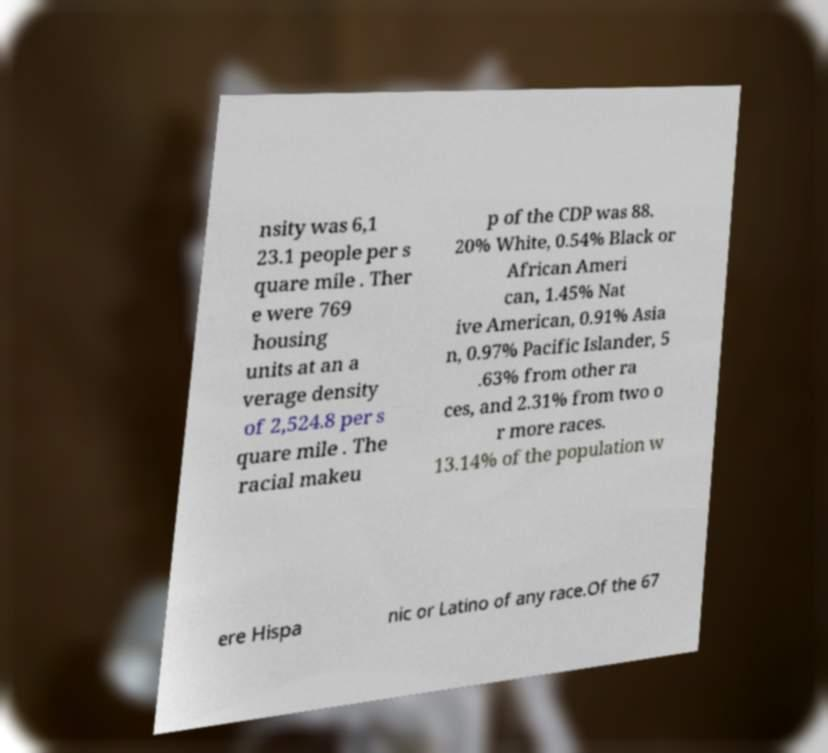Could you extract and type out the text from this image? nsity was 6,1 23.1 people per s quare mile . Ther e were 769 housing units at an a verage density of 2,524.8 per s quare mile . The racial makeu p of the CDP was 88. 20% White, 0.54% Black or African Ameri can, 1.45% Nat ive American, 0.91% Asia n, 0.97% Pacific Islander, 5 .63% from other ra ces, and 2.31% from two o r more races. 13.14% of the population w ere Hispa nic or Latino of any race.Of the 67 